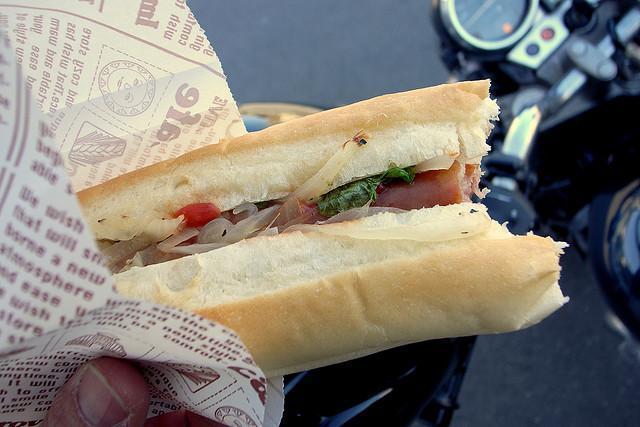How many cars have zebra stripes?
Give a very brief answer. 0. 